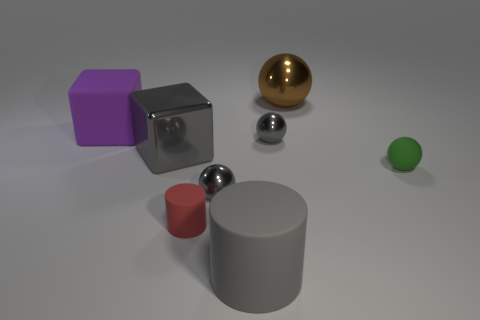What is the color of the other large shiny object that is the same shape as the big purple thing?
Provide a short and direct response. Gray. How many big objects are either brown objects or rubber balls?
Give a very brief answer. 1. What is the size of the thing to the right of the large metallic ball?
Your response must be concise. Small. Is there a small shiny sphere of the same color as the rubber sphere?
Your response must be concise. No. Does the big rubber cylinder have the same color as the small cylinder?
Provide a succinct answer. No. There is a large shiny thing that is the same color as the big rubber cylinder; what shape is it?
Your response must be concise. Cube. How many big gray metallic things are on the left side of the gray cylinder in front of the small green object?
Provide a short and direct response. 1. How many tiny things are made of the same material as the red cylinder?
Give a very brief answer. 1. There is a red matte object; are there any small matte things in front of it?
Provide a short and direct response. No. The matte cylinder that is the same size as the green thing is what color?
Provide a succinct answer. Red. 